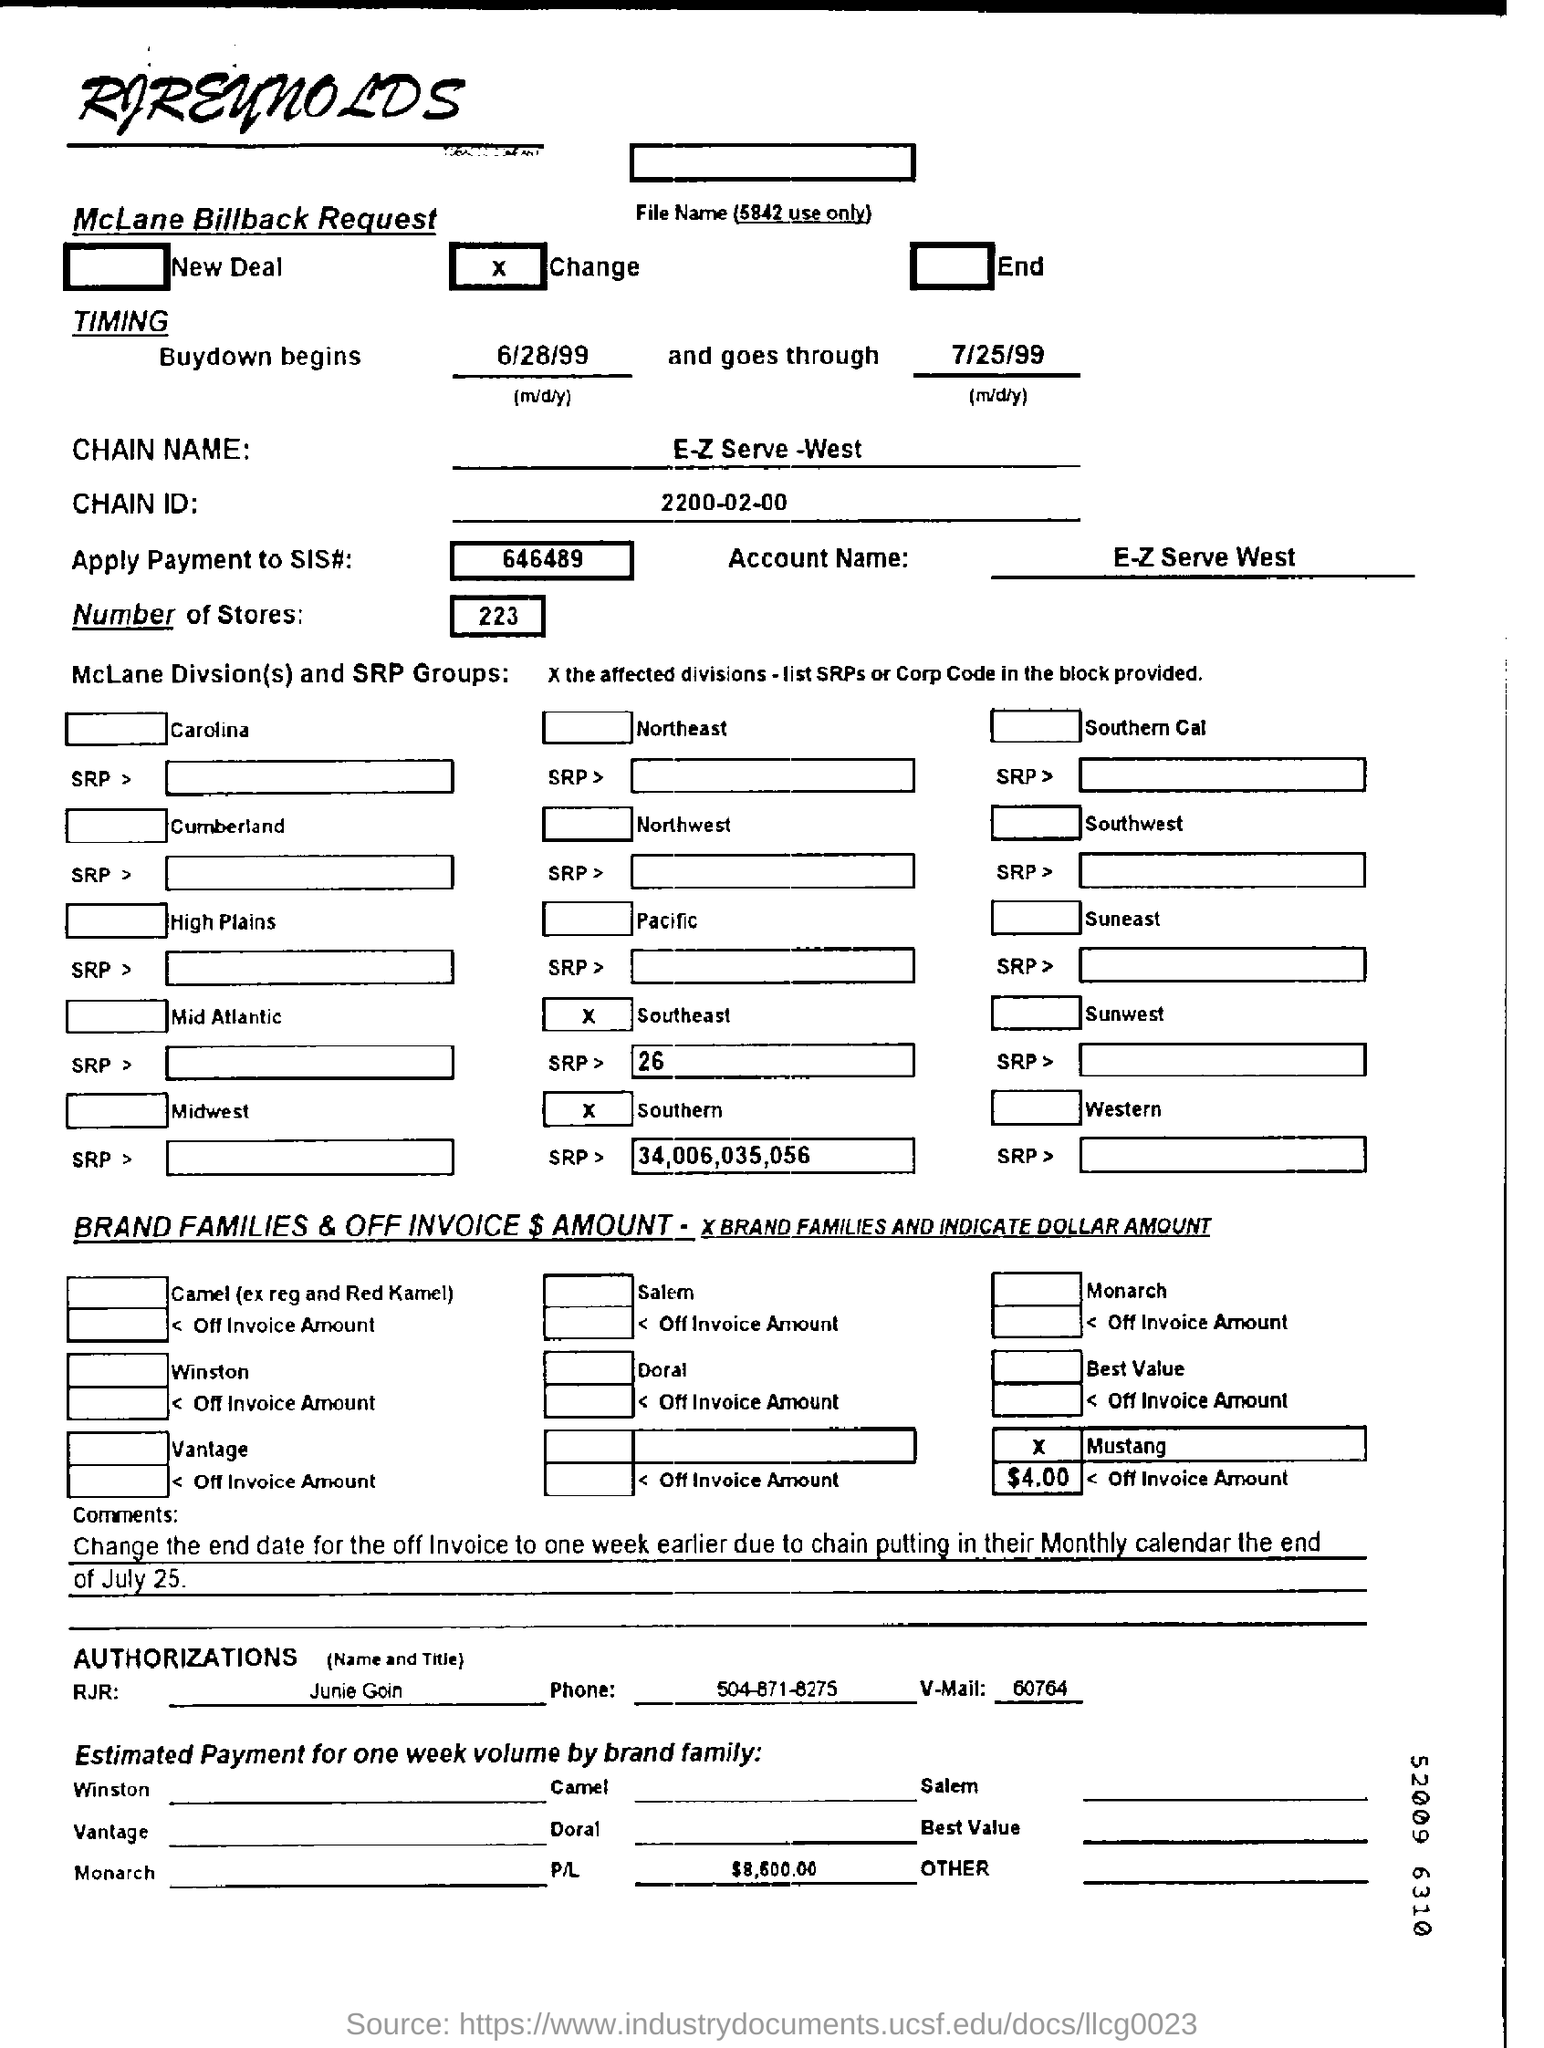What is the ACCOUNT NAME?
Give a very brief answer. E-Z Serve West. How many stores are there?
Your answer should be very brief. 223. What is the Apply Payment to SIS#?
Keep it short and to the point. 646489. Who is the RJR mentioned?
Keep it short and to the point. Junie Goin. 